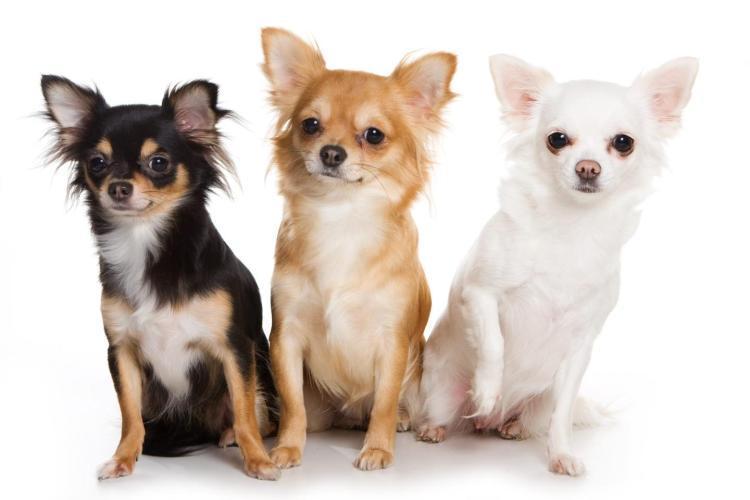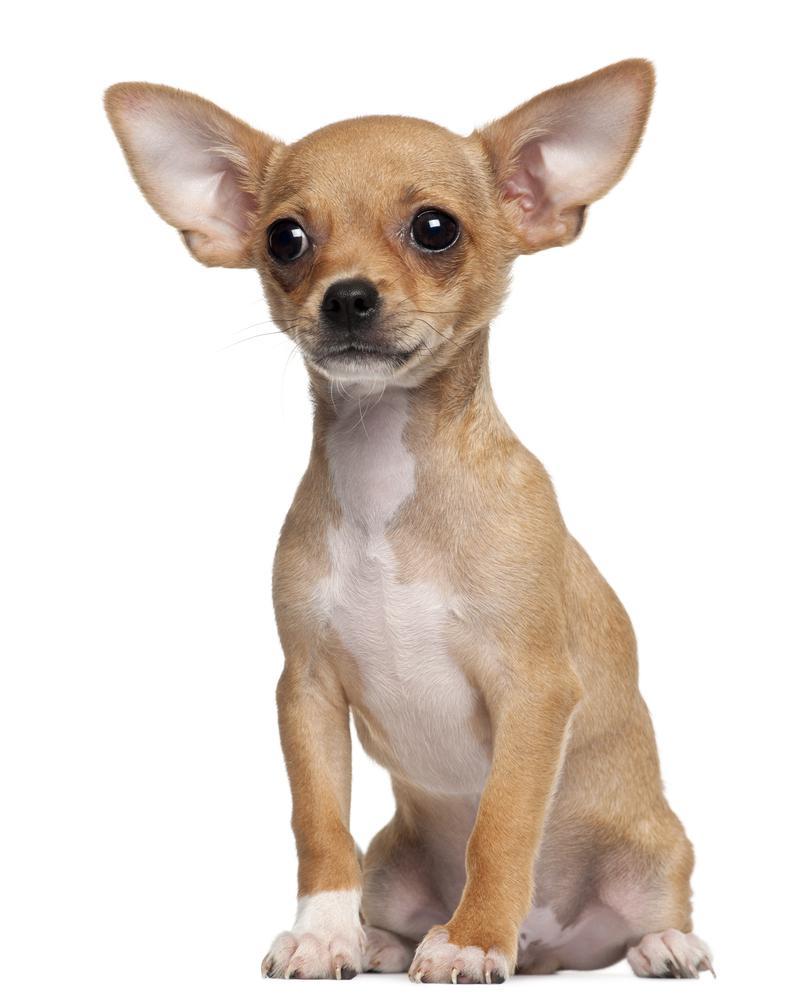The first image is the image on the left, the second image is the image on the right. Given the left and right images, does the statement "One of the images shows a pair of dogs with the white and gray dog holding a paw up." hold true? Answer yes or no. No. The first image is the image on the left, the second image is the image on the right. Examine the images to the left and right. Is the description "Images show a total of four dogs, and all dogs are sitting upright." accurate? Answer yes or no. Yes. 